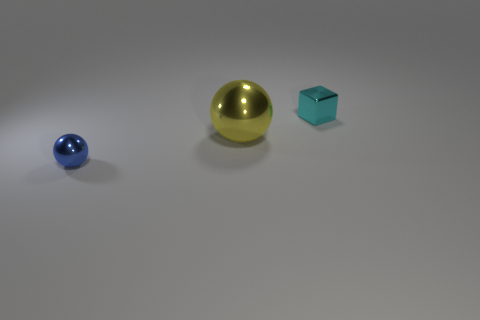Subtract all yellow balls. How many balls are left? 1 Subtract all cubes. How many objects are left? 2 Add 1 tiny gray things. How many objects exist? 4 Add 3 small red cubes. How many small red cubes exist? 3 Subtract 0 gray balls. How many objects are left? 3 Subtract all cyan blocks. Subtract all tiny cyan metallic cubes. How many objects are left? 1 Add 2 metallic spheres. How many metallic spheres are left? 4 